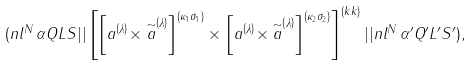<formula> <loc_0><loc_0><loc_500><loc_500>( n l ^ { N } \, \alpha Q L S | | \left [ \left [ a ^ { \left ( \lambda \right ) } \times \stackrel { \sim } { a } ^ { \left ( \lambda \right ) } \right ] ^ { \left ( \kappa _ { 1 } \sigma _ { 1 } \right ) } \times \left [ a ^ { \left ( \lambda \right ) } \times \stackrel { \sim } { a } ^ { \left ( \lambda \right ) } \right ] ^ { \left ( \kappa _ { 2 } \sigma _ { 2 } \right ) } \right ] ^ { \left ( k k \right ) } | | n l ^ { N } \, \alpha ^ { \prime } Q ^ { \prime } L ^ { \prime } S ^ { \prime } ) ,</formula> 